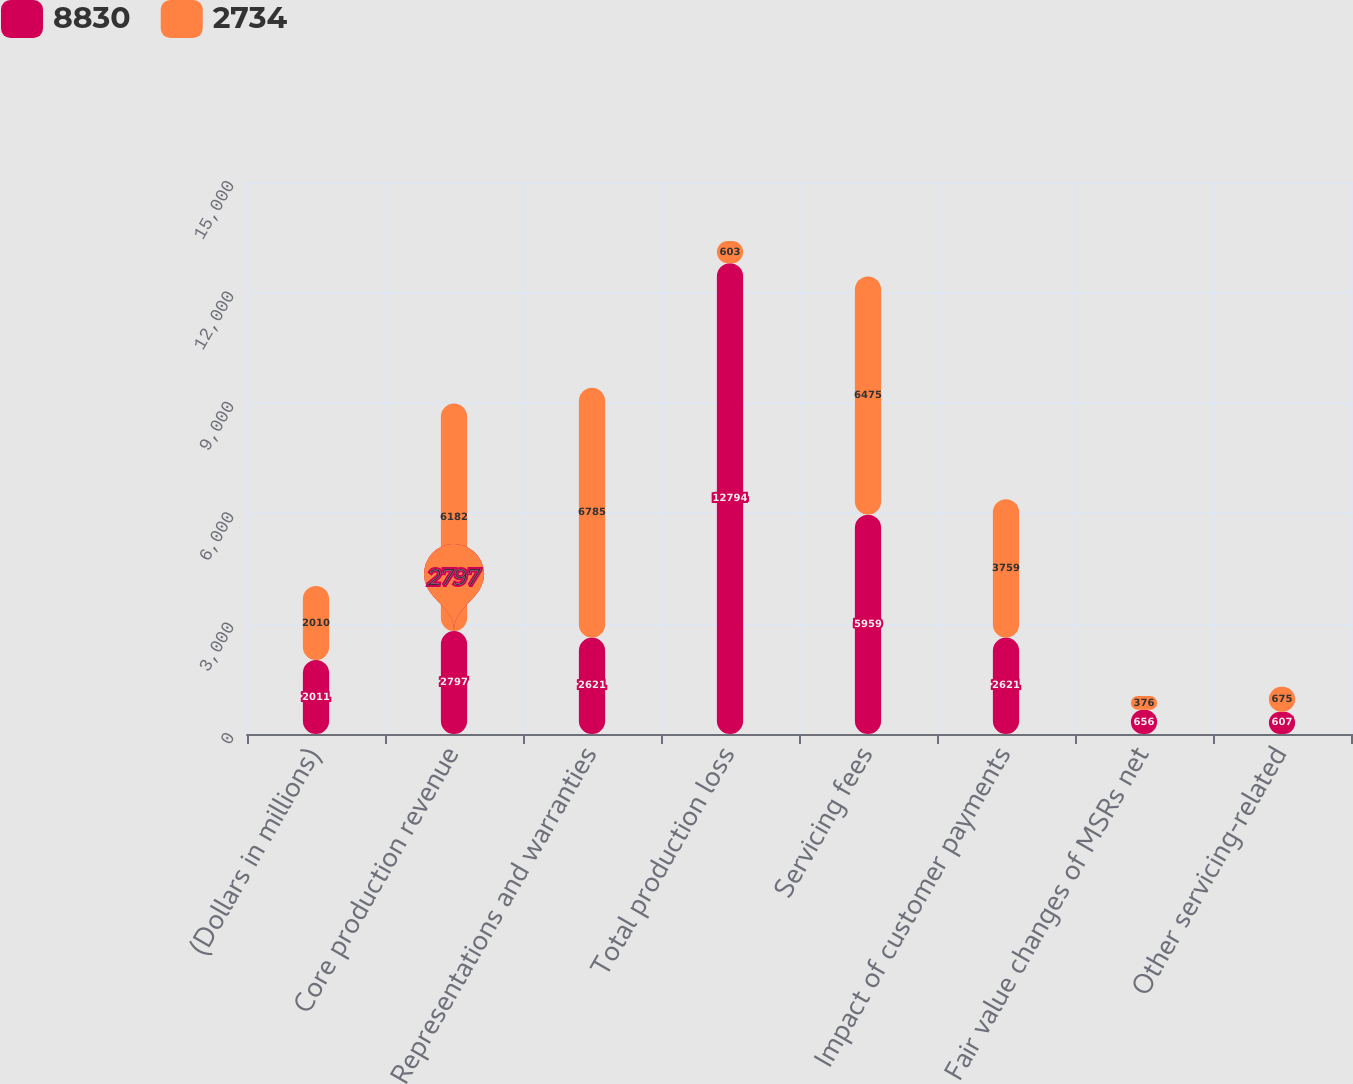Convert chart. <chart><loc_0><loc_0><loc_500><loc_500><stacked_bar_chart><ecel><fcel>(Dollars in millions)<fcel>Core production revenue<fcel>Representations and warranties<fcel>Total production loss<fcel>Servicing fees<fcel>Impact of customer payments<fcel>Fair value changes of MSRs net<fcel>Other servicing-related<nl><fcel>8830<fcel>2011<fcel>2797<fcel>2621<fcel>12794<fcel>5959<fcel>2621<fcel>656<fcel>607<nl><fcel>2734<fcel>2010<fcel>6182<fcel>6785<fcel>603<fcel>6475<fcel>3759<fcel>376<fcel>675<nl></chart> 